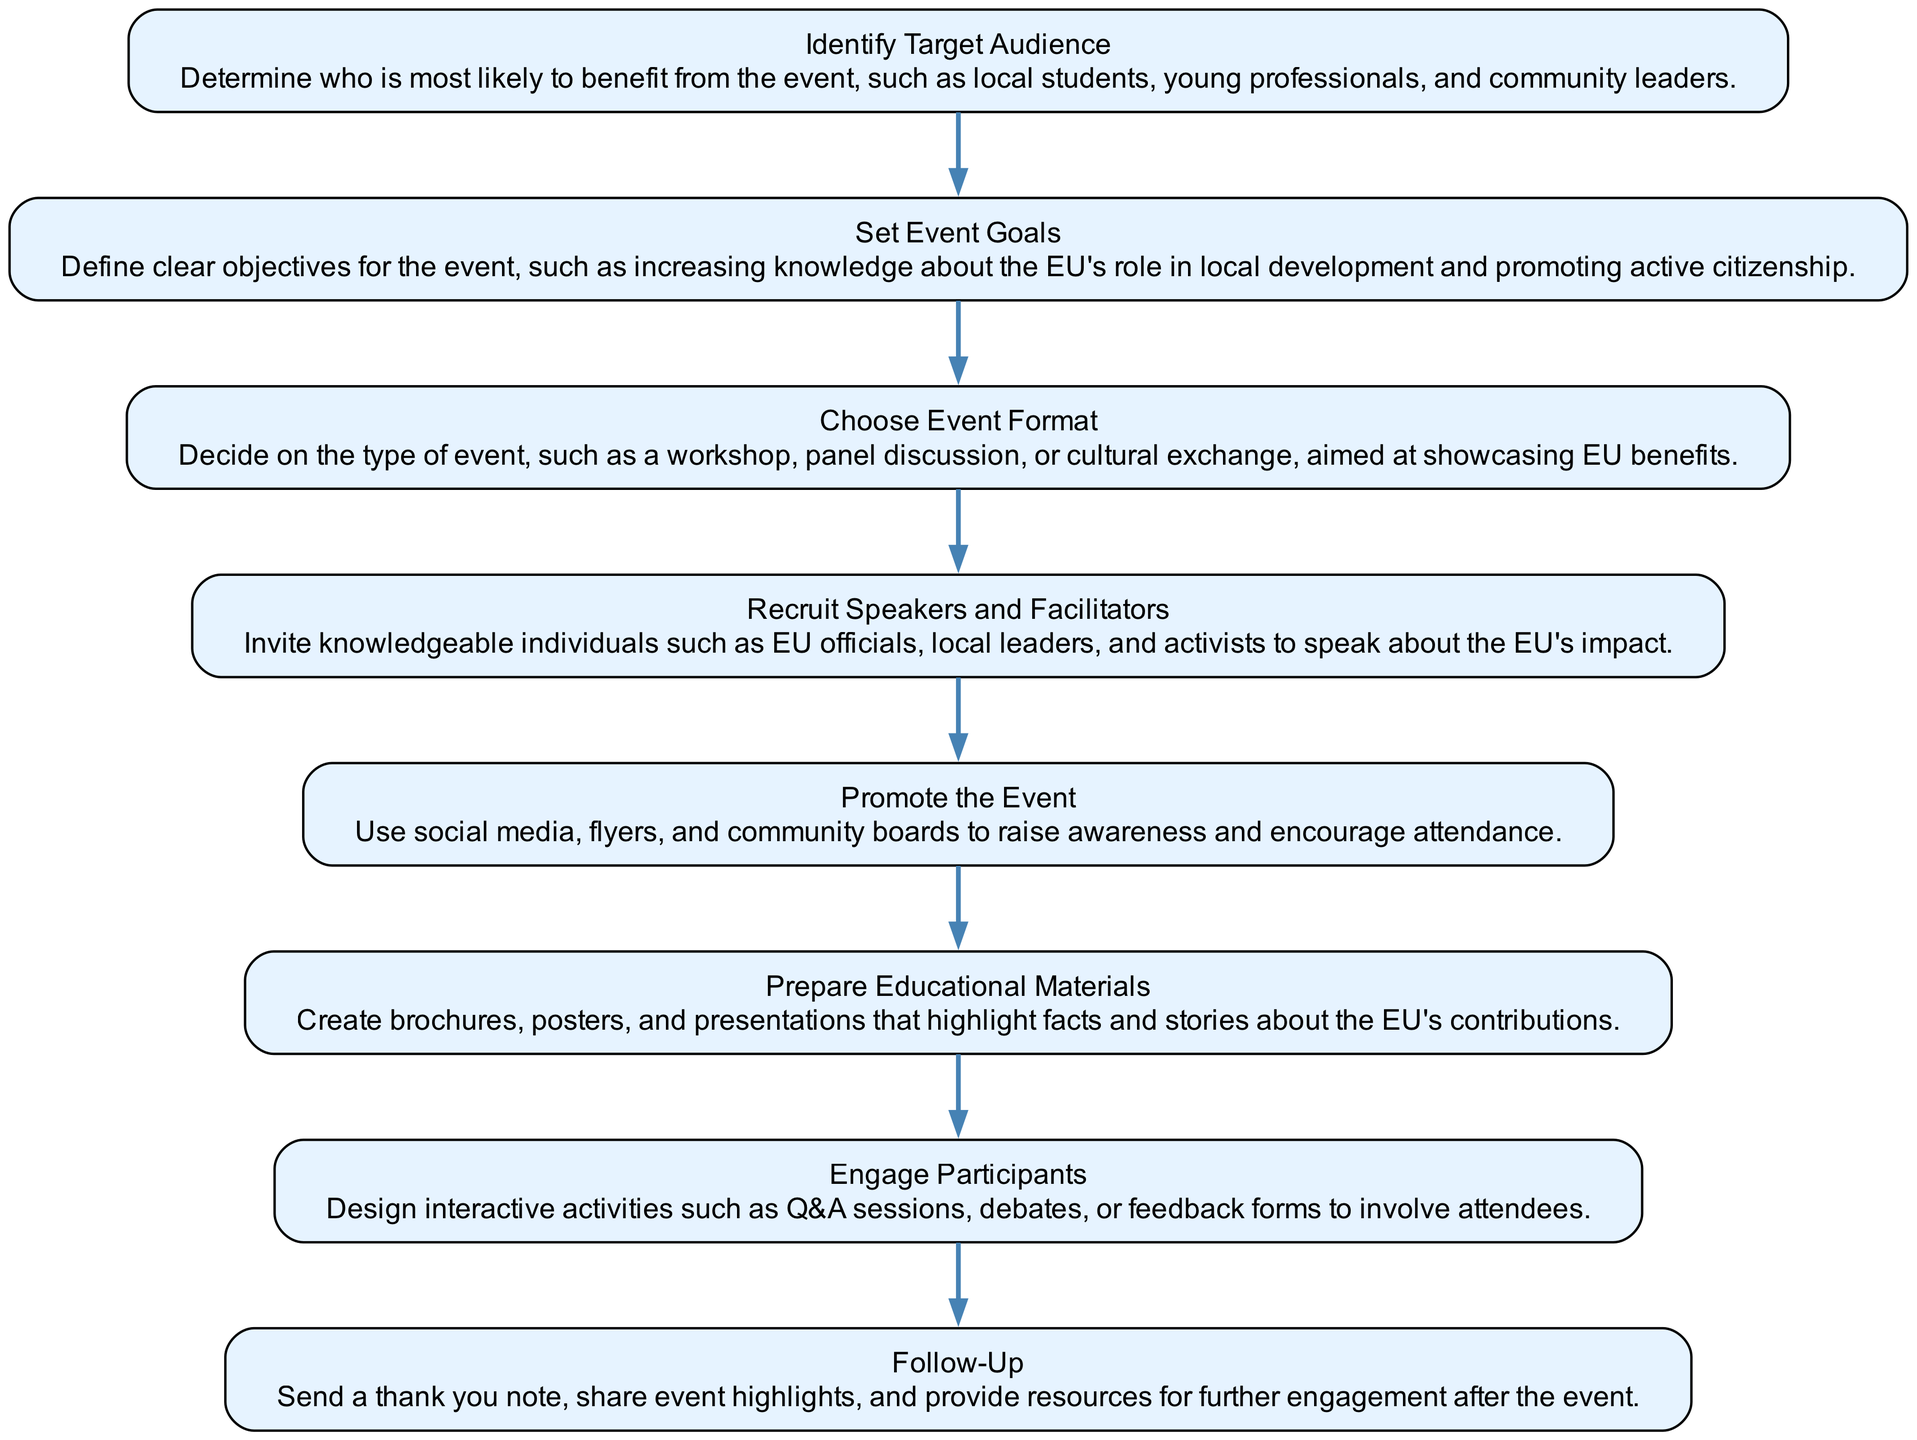What is the first step in organizing the event? The first step shown in the sequence diagram is "Identify Target Audience." This means it is the initial action that must be taken before moving to the next steps.
Answer: Identify Target Audience How many total steps are there in the event organization sequence? By counting the nodes in the diagram, we see there are a total of eight steps involved in organizing the event.
Answer: Eight Which step follows "Choose Event Format"? The step that follows "Choose Event Format" is "Recruit Speakers and Facilitators." This indicates that once the format is chosen, the next action is to secure speakers.
Answer: Recruit Speakers and Facilitators What is the purpose of "Promote the Event"? The purpose of "Promote the Event" is to raise awareness and encourage attendance, as indicated in the description associated with that step.
Answer: Raise awareness and encourage attendance What are two types of activities included in "Engage Participants"? The description for "Engage Participants" mentions interactive activities such as Q&A sessions and debates, which serve to involve attendees effectively.
Answer: Q&A sessions, debates What is the last step in the sequence diagram? The last step in the sequence diagram is "Follow-Up." This indicates that there is a concluding action after the main event has taken place, ensuring continued engagement.
Answer: Follow-Up How does the step "Prepare Educational Materials" contribute to the event? "Prepare Educational Materials" is intended to create brochures, posters, and presentations that highlight EU benefits. This preparation is crucial for educating attendees about the topic.
Answer: Educating attendees about EU benefits Which step emphasizes the importance of setting event goals? The step that emphasizes setting event goals is "Set Event Goals," as it focuses on defining clear objectives for the event, showcasing its significance.
Answer: Set Event Goals 